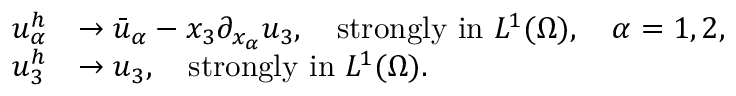<formula> <loc_0><loc_0><loc_500><loc_500>\begin{array} { r l } { u _ { \alpha } ^ { h } } & { \to \bar { u } _ { \alpha } - x _ { 3 } \partial _ { x _ { \alpha } } u _ { 3 } , \quad s t r o n g l y i n L ^ { 1 } ( \Omega ) , \quad \alpha = 1 , 2 , } \\ { u _ { 3 } ^ { h } } & { \to u _ { 3 } , \quad s t r o n g l y i n L ^ { 1 } ( \Omega ) . } \end{array}</formula> 